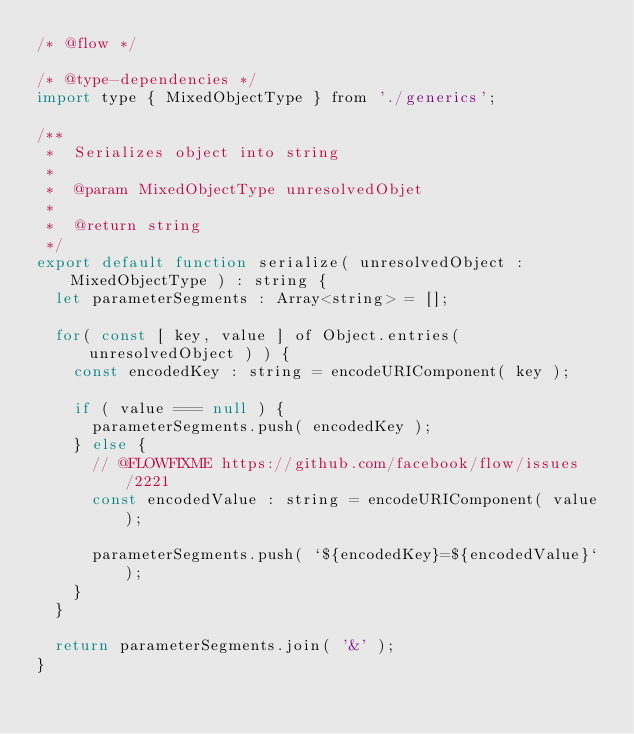<code> <loc_0><loc_0><loc_500><loc_500><_JavaScript_>/* @flow */

/* @type-dependencies */
import type { MixedObjectType } from './generics';

/**
 *	Serializes object into string
 *
 *	@param MixedObjectType unresolvedObjet
 *
 *	@return string
 */
export default function serialize( unresolvedObject : MixedObjectType ) : string {
	let parameterSegments : Array<string> = [];

	for( const [ key, value ] of Object.entries( unresolvedObject ) ) {
		const encodedKey : string = encodeURIComponent( key );

		if ( value === null ) {
			parameterSegments.push( encodedKey );
		} else {
			// @FLOWFIXME https://github.com/facebook/flow/issues/2221
			const encodedValue : string = encodeURIComponent( value );

			parameterSegments.push( `${encodedKey}=${encodedValue}` );
		}
	}

	return parameterSegments.join( '&' );
}
</code> 